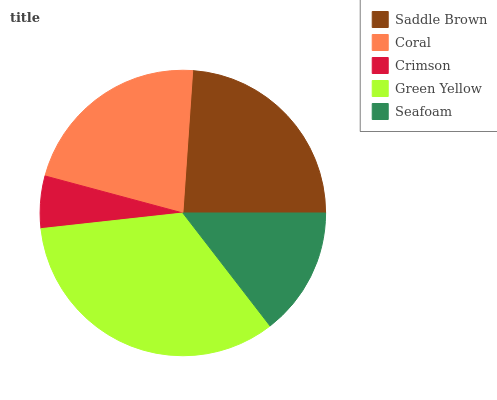Is Crimson the minimum?
Answer yes or no. Yes. Is Green Yellow the maximum?
Answer yes or no. Yes. Is Coral the minimum?
Answer yes or no. No. Is Coral the maximum?
Answer yes or no. No. Is Saddle Brown greater than Coral?
Answer yes or no. Yes. Is Coral less than Saddle Brown?
Answer yes or no. Yes. Is Coral greater than Saddle Brown?
Answer yes or no. No. Is Saddle Brown less than Coral?
Answer yes or no. No. Is Coral the high median?
Answer yes or no. Yes. Is Coral the low median?
Answer yes or no. Yes. Is Green Yellow the high median?
Answer yes or no. No. Is Seafoam the low median?
Answer yes or no. No. 